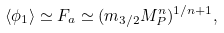Convert formula to latex. <formula><loc_0><loc_0><loc_500><loc_500>\langle \phi _ { 1 } \rangle \simeq F _ { a } \simeq ( m _ { 3 / 2 } M _ { P } ^ { n } ) ^ { 1 / n + 1 } ,</formula> 